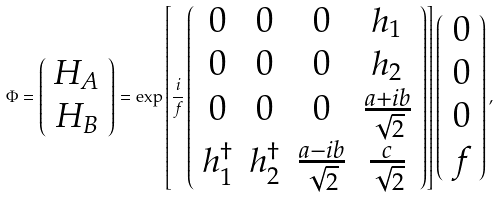Convert formula to latex. <formula><loc_0><loc_0><loc_500><loc_500>\Phi = \left ( \begin{array} { c } H _ { A } \\ H _ { B } \end{array} \right ) = \exp \left [ \frac { i } { f } \left ( \begin{array} { c c c c } 0 & 0 & 0 & h _ { 1 } \\ 0 & 0 & 0 & h _ { 2 } \\ 0 & 0 & 0 & \frac { a + i b } { \sqrt { 2 } } \\ h _ { 1 } ^ { \dagger } & h _ { 2 } ^ { \dagger } & \frac { a - i b } { \sqrt { 2 } } & \frac { c } { \sqrt { 2 } } \end{array} \right ) \right ] \left ( \begin{array} { c } 0 \\ 0 \\ 0 \\ f \end{array} \right ) ,</formula> 